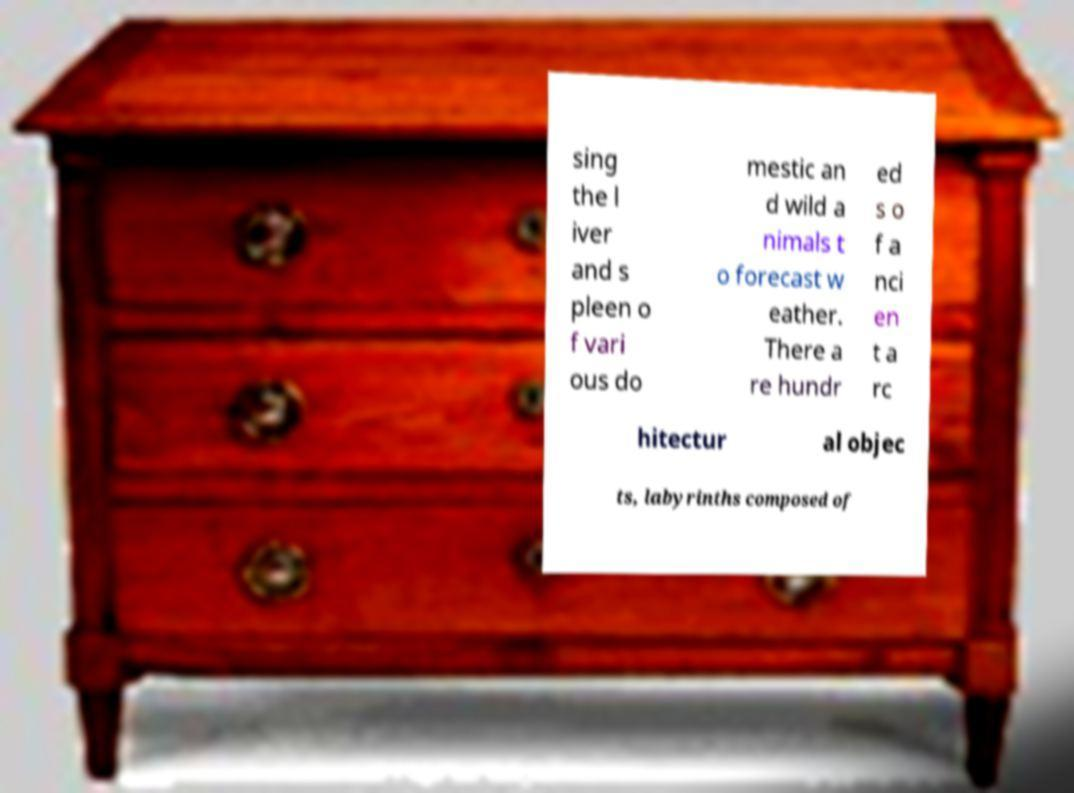For documentation purposes, I need the text within this image transcribed. Could you provide that? sing the l iver and s pleen o f vari ous do mestic an d wild a nimals t o forecast w eather. There a re hundr ed s o f a nci en t a rc hitectur al objec ts, labyrinths composed of 